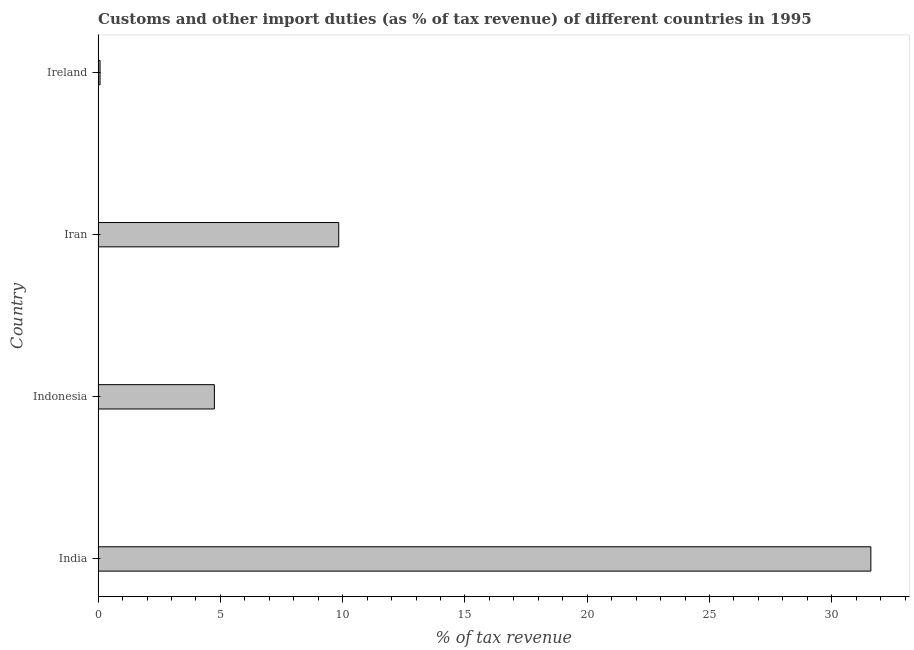What is the title of the graph?
Your response must be concise. Customs and other import duties (as % of tax revenue) of different countries in 1995. What is the label or title of the X-axis?
Provide a succinct answer. % of tax revenue. What is the customs and other import duties in Indonesia?
Give a very brief answer. 4.75. Across all countries, what is the maximum customs and other import duties?
Your answer should be compact. 31.6. Across all countries, what is the minimum customs and other import duties?
Offer a very short reply. 0.08. In which country was the customs and other import duties maximum?
Give a very brief answer. India. In which country was the customs and other import duties minimum?
Your response must be concise. Ireland. What is the sum of the customs and other import duties?
Your answer should be compact. 46.27. What is the difference between the customs and other import duties in Indonesia and Iran?
Keep it short and to the point. -5.08. What is the average customs and other import duties per country?
Ensure brevity in your answer.  11.57. What is the median customs and other import duties?
Ensure brevity in your answer.  7.3. In how many countries, is the customs and other import duties greater than 19 %?
Your answer should be compact. 1. What is the ratio of the customs and other import duties in Indonesia to that in Ireland?
Ensure brevity in your answer.  60.31. What is the difference between the highest and the second highest customs and other import duties?
Your answer should be very brief. 21.76. What is the difference between the highest and the lowest customs and other import duties?
Offer a very short reply. 31.52. In how many countries, is the customs and other import duties greater than the average customs and other import duties taken over all countries?
Ensure brevity in your answer.  1. How many bars are there?
Provide a short and direct response. 4. Are all the bars in the graph horizontal?
Give a very brief answer. Yes. What is the difference between two consecutive major ticks on the X-axis?
Offer a very short reply. 5. What is the % of tax revenue of India?
Your answer should be very brief. 31.6. What is the % of tax revenue in Indonesia?
Your answer should be compact. 4.75. What is the % of tax revenue in Iran?
Make the answer very short. 9.84. What is the % of tax revenue in Ireland?
Offer a very short reply. 0.08. What is the difference between the % of tax revenue in India and Indonesia?
Provide a short and direct response. 26.84. What is the difference between the % of tax revenue in India and Iran?
Provide a succinct answer. 21.76. What is the difference between the % of tax revenue in India and Ireland?
Give a very brief answer. 31.52. What is the difference between the % of tax revenue in Indonesia and Iran?
Your answer should be compact. -5.09. What is the difference between the % of tax revenue in Indonesia and Ireland?
Ensure brevity in your answer.  4.67. What is the difference between the % of tax revenue in Iran and Ireland?
Offer a terse response. 9.76. What is the ratio of the % of tax revenue in India to that in Indonesia?
Your answer should be compact. 6.65. What is the ratio of the % of tax revenue in India to that in Iran?
Offer a very short reply. 3.21. What is the ratio of the % of tax revenue in India to that in Ireland?
Your response must be concise. 400.88. What is the ratio of the % of tax revenue in Indonesia to that in Iran?
Offer a terse response. 0.48. What is the ratio of the % of tax revenue in Indonesia to that in Ireland?
Offer a terse response. 60.31. What is the ratio of the % of tax revenue in Iran to that in Ireland?
Provide a short and direct response. 124.82. 